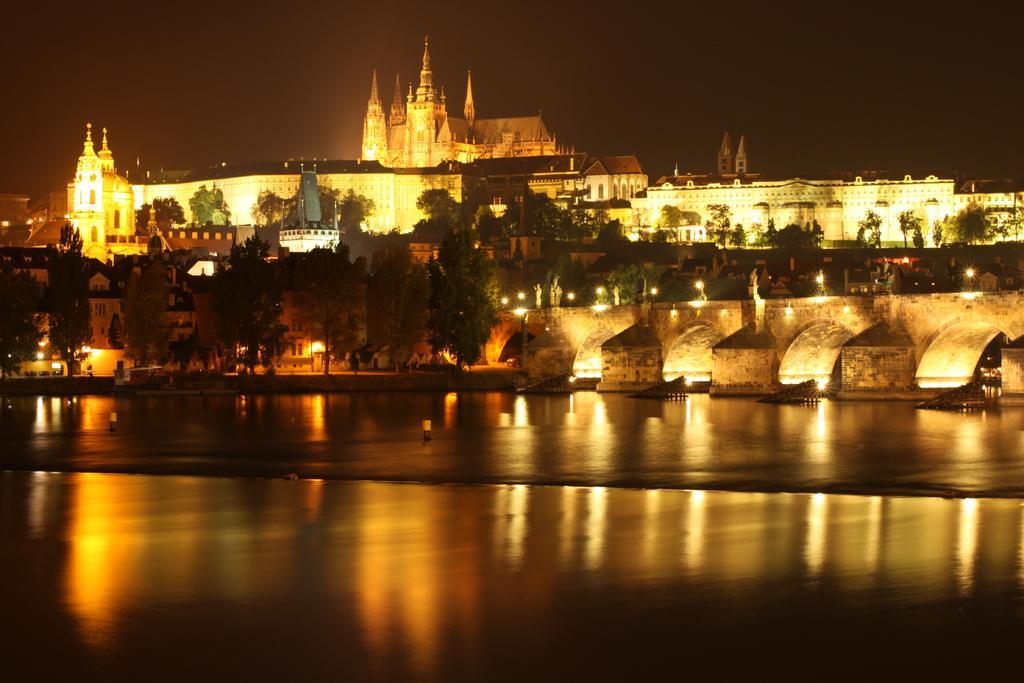Please provide a concise description of this image. In this image, we can see few bungalows, buildings, trees, bridge, lights, water. Background there is a sky. 